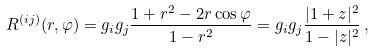Convert formula to latex. <formula><loc_0><loc_0><loc_500><loc_500>R ^ { ( i j ) } ( r , \varphi ) = g _ { i } g _ { j } \frac { 1 + r ^ { 2 } - 2 r \cos \varphi } { 1 - r ^ { 2 } } = g _ { i } g _ { j } \frac { | 1 + z | ^ { 2 } } { 1 - | z | ^ { 2 } } \, ,</formula> 